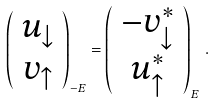Convert formula to latex. <formula><loc_0><loc_0><loc_500><loc_500>\left ( \begin{array} { c } u _ { \downarrow } \\ v _ { \uparrow } \end{array} \right ) _ { - E } = \left ( \begin{array} { c } - v _ { \downarrow } ^ { * } \\ u _ { \uparrow } ^ { * } \end{array} \right ) _ { E } \, .</formula> 